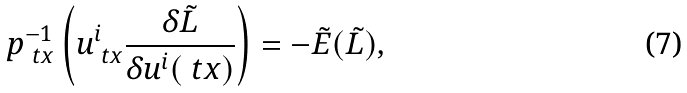Convert formula to latex. <formula><loc_0><loc_0><loc_500><loc_500>\ p _ { \ t x } ^ { - 1 } \left ( u ^ { i } _ { \ t x } \frac { \delta \tilde { L } } { \delta u ^ { i } ( \ t x ) } \right ) = - \tilde { E } ( \tilde { L } ) ,</formula> 